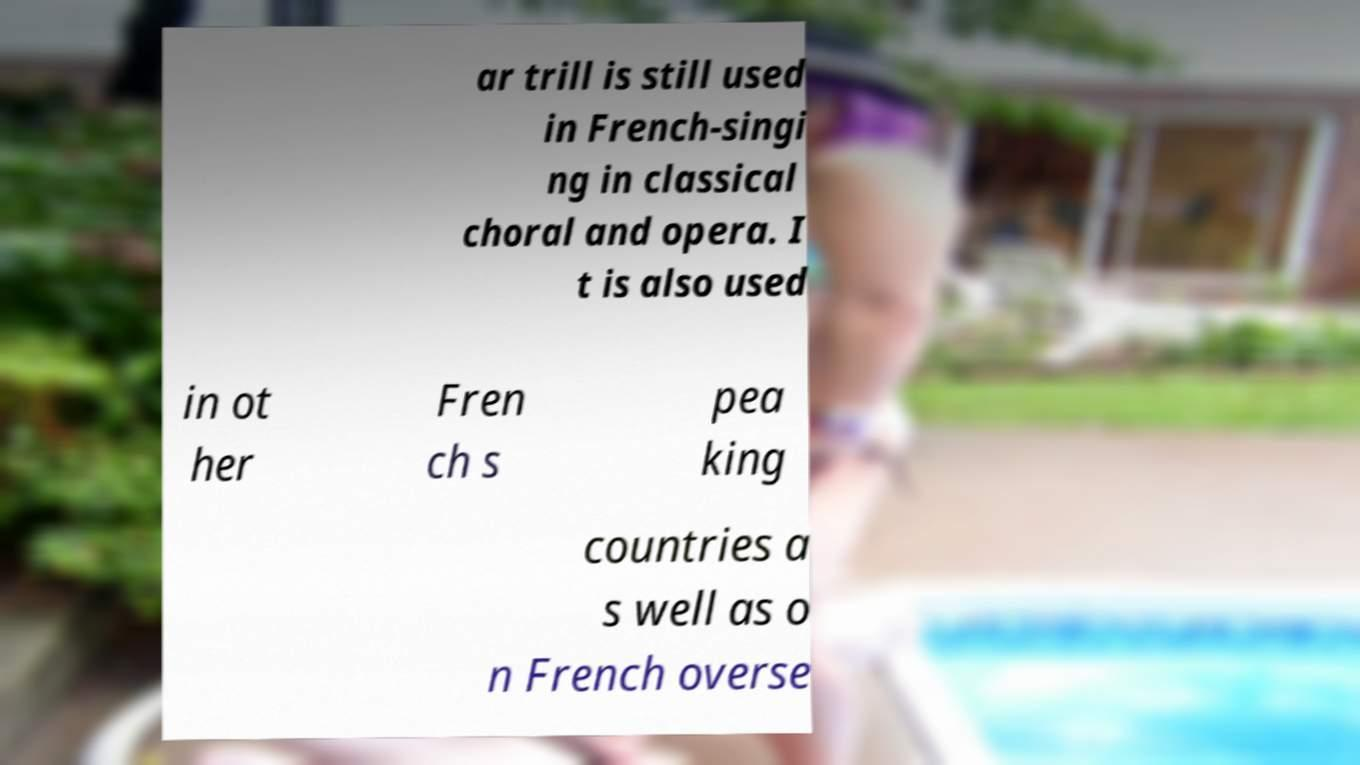I need the written content from this picture converted into text. Can you do that? ar trill is still used in French-singi ng in classical choral and opera. I t is also used in ot her Fren ch s pea king countries a s well as o n French overse 